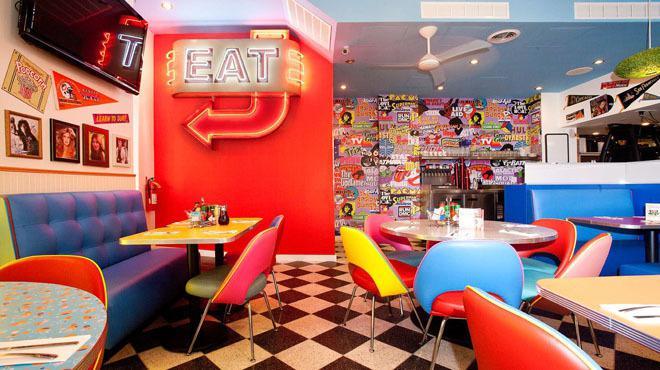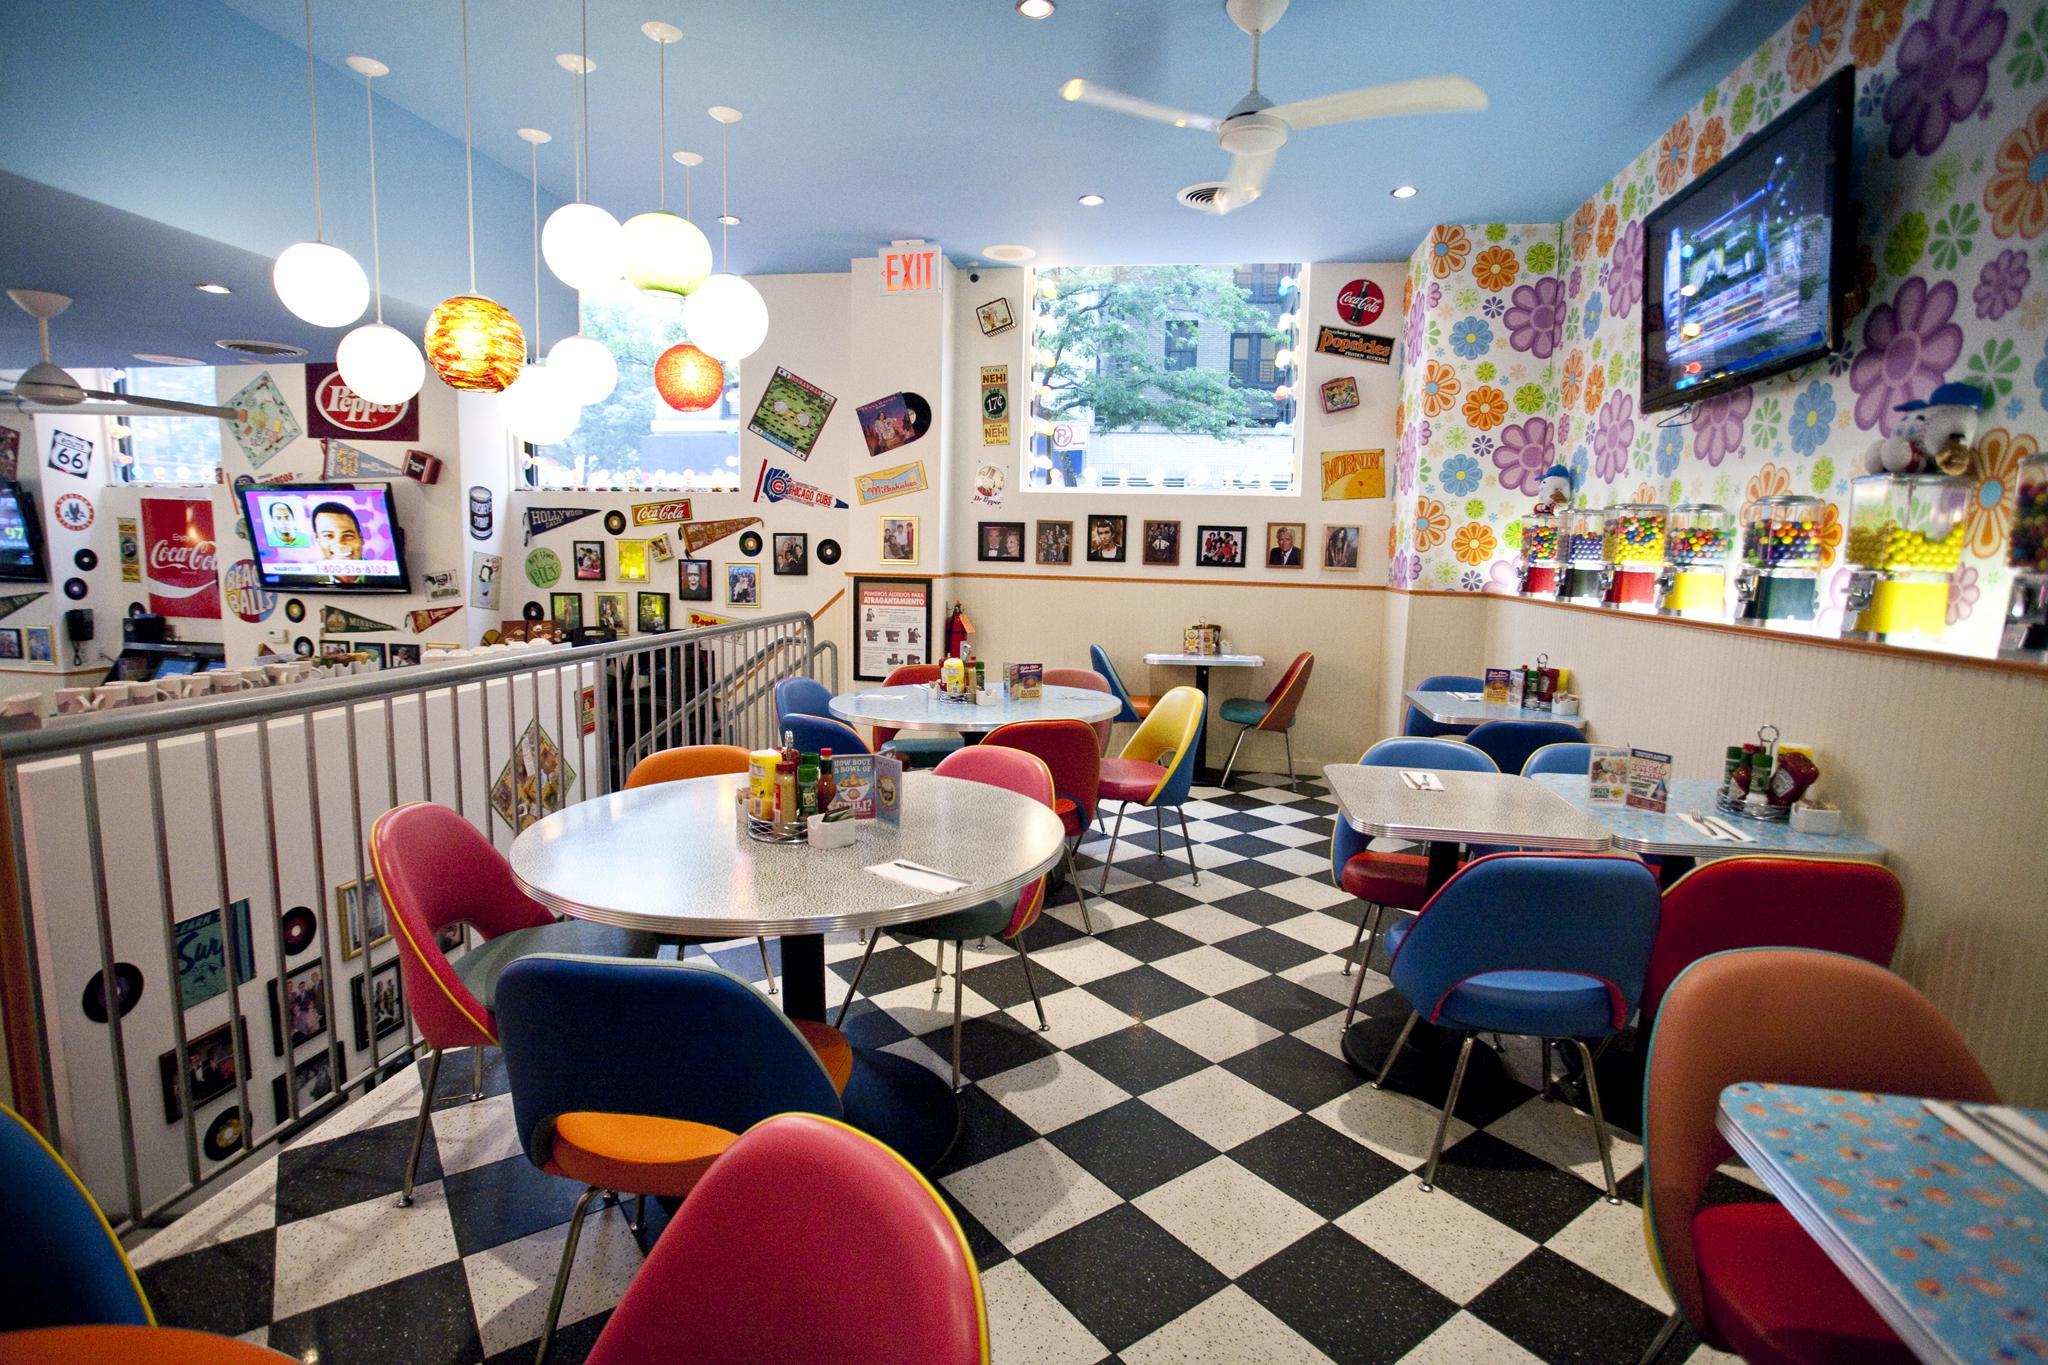The first image is the image on the left, the second image is the image on the right. Considering the images on both sides, is "There are two empty cafes with no more than one person in the whole image." valid? Answer yes or no. Yes. 